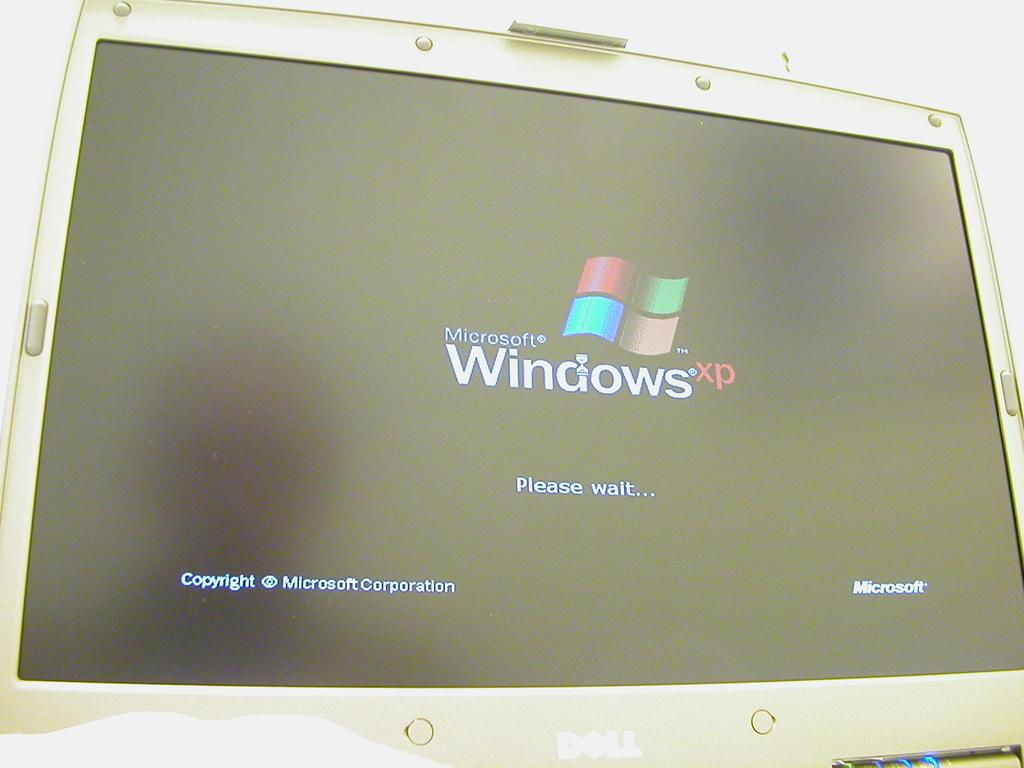<image>
Render a clear and concise summary of the photo. A computer monitor showing the starting screen for Microsoft Windows XP. 